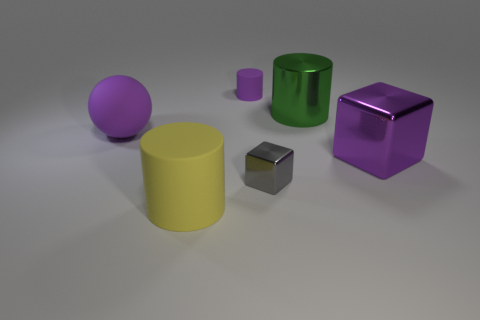There is a purple object that is behind the large green shiny cylinder that is right of the tiny purple matte cylinder; is there a gray object that is behind it?
Keep it short and to the point. No. Is there any other thing of the same color as the big matte sphere?
Keep it short and to the point. Yes. How big is the purple matte thing that is to the left of the small cylinder?
Offer a very short reply. Large. There is a matte cylinder that is right of the matte cylinder that is in front of the metal thing that is on the left side of the green metal cylinder; what is its size?
Offer a very short reply. Small. There is a big metal thing that is in front of the purple thing on the left side of the small purple thing; what is its color?
Give a very brief answer. Purple. There is a big thing that is the same shape as the small gray metallic object; what is its material?
Ensure brevity in your answer.  Metal. Is there any other thing that has the same material as the big green cylinder?
Your response must be concise. Yes. Are there any rubber cylinders behind the small rubber thing?
Give a very brief answer. No. What number of large green metallic things are there?
Give a very brief answer. 1. What number of rubber spheres are in front of the tiny thing in front of the matte ball?
Give a very brief answer. 0. 